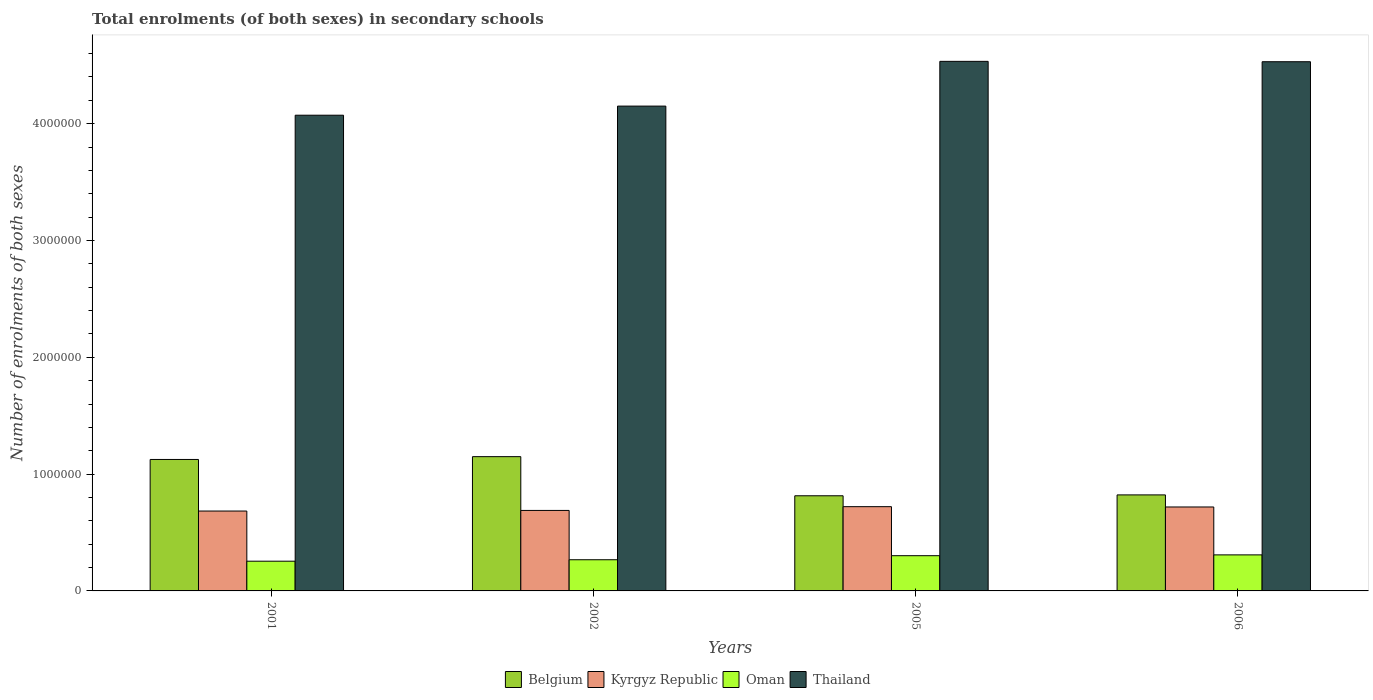How many groups of bars are there?
Ensure brevity in your answer.  4. Are the number of bars per tick equal to the number of legend labels?
Offer a very short reply. Yes. How many bars are there on the 3rd tick from the left?
Offer a terse response. 4. What is the label of the 1st group of bars from the left?
Ensure brevity in your answer.  2001. In how many cases, is the number of bars for a given year not equal to the number of legend labels?
Your answer should be very brief. 0. What is the number of enrolments in secondary schools in Belgium in 2005?
Your answer should be compact. 8.15e+05. Across all years, what is the maximum number of enrolments in secondary schools in Thailand?
Your response must be concise. 4.53e+06. Across all years, what is the minimum number of enrolments in secondary schools in Kyrgyz Republic?
Keep it short and to the point. 6.84e+05. What is the total number of enrolments in secondary schools in Belgium in the graph?
Ensure brevity in your answer.  3.91e+06. What is the difference between the number of enrolments in secondary schools in Belgium in 2001 and that in 2005?
Your response must be concise. 3.11e+05. What is the difference between the number of enrolments in secondary schools in Kyrgyz Republic in 2005 and the number of enrolments in secondary schools in Oman in 2001?
Your answer should be compact. 4.67e+05. What is the average number of enrolments in secondary schools in Oman per year?
Your response must be concise. 2.83e+05. In the year 2001, what is the difference between the number of enrolments in secondary schools in Oman and number of enrolments in secondary schools in Kyrgyz Republic?
Give a very brief answer. -4.29e+05. What is the ratio of the number of enrolments in secondary schools in Kyrgyz Republic in 2005 to that in 2006?
Ensure brevity in your answer.  1. Is the difference between the number of enrolments in secondary schools in Oman in 2001 and 2006 greater than the difference between the number of enrolments in secondary schools in Kyrgyz Republic in 2001 and 2006?
Give a very brief answer. No. What is the difference between the highest and the second highest number of enrolments in secondary schools in Oman?
Offer a terse response. 6940. What is the difference between the highest and the lowest number of enrolments in secondary schools in Oman?
Offer a terse response. 5.40e+04. In how many years, is the number of enrolments in secondary schools in Belgium greater than the average number of enrolments in secondary schools in Belgium taken over all years?
Make the answer very short. 2. Is the sum of the number of enrolments in secondary schools in Kyrgyz Republic in 2005 and 2006 greater than the maximum number of enrolments in secondary schools in Belgium across all years?
Provide a succinct answer. Yes. What does the 4th bar from the left in 2006 represents?
Provide a short and direct response. Thailand. What does the 1st bar from the right in 2001 represents?
Give a very brief answer. Thailand. How many bars are there?
Provide a short and direct response. 16. What is the difference between two consecutive major ticks on the Y-axis?
Offer a very short reply. 1.00e+06. Are the values on the major ticks of Y-axis written in scientific E-notation?
Provide a short and direct response. No. Does the graph contain any zero values?
Your answer should be very brief. No. Does the graph contain grids?
Keep it short and to the point. No. Where does the legend appear in the graph?
Offer a terse response. Bottom center. How are the legend labels stacked?
Your answer should be compact. Horizontal. What is the title of the graph?
Make the answer very short. Total enrolments (of both sexes) in secondary schools. Does "Isle of Man" appear as one of the legend labels in the graph?
Provide a succinct answer. No. What is the label or title of the X-axis?
Offer a very short reply. Years. What is the label or title of the Y-axis?
Offer a very short reply. Number of enrolments of both sexes. What is the Number of enrolments of both sexes of Belgium in 2001?
Provide a short and direct response. 1.13e+06. What is the Number of enrolments of both sexes of Kyrgyz Republic in 2001?
Provide a succinct answer. 6.84e+05. What is the Number of enrolments of both sexes in Oman in 2001?
Keep it short and to the point. 2.54e+05. What is the Number of enrolments of both sexes in Thailand in 2001?
Your response must be concise. 4.07e+06. What is the Number of enrolments of both sexes of Belgium in 2002?
Ensure brevity in your answer.  1.15e+06. What is the Number of enrolments of both sexes of Kyrgyz Republic in 2002?
Ensure brevity in your answer.  6.89e+05. What is the Number of enrolments of both sexes of Oman in 2002?
Your answer should be very brief. 2.67e+05. What is the Number of enrolments of both sexes of Thailand in 2002?
Your response must be concise. 4.15e+06. What is the Number of enrolments of both sexes in Belgium in 2005?
Provide a short and direct response. 8.15e+05. What is the Number of enrolments of both sexes of Kyrgyz Republic in 2005?
Your answer should be compact. 7.21e+05. What is the Number of enrolments of both sexes of Oman in 2005?
Ensure brevity in your answer.  3.02e+05. What is the Number of enrolments of both sexes in Thailand in 2005?
Ensure brevity in your answer.  4.53e+06. What is the Number of enrolments of both sexes in Belgium in 2006?
Your answer should be very brief. 8.22e+05. What is the Number of enrolments of both sexes in Kyrgyz Republic in 2006?
Provide a succinct answer. 7.19e+05. What is the Number of enrolments of both sexes in Oman in 2006?
Make the answer very short. 3.09e+05. What is the Number of enrolments of both sexes in Thailand in 2006?
Your answer should be compact. 4.53e+06. Across all years, what is the maximum Number of enrolments of both sexes in Belgium?
Keep it short and to the point. 1.15e+06. Across all years, what is the maximum Number of enrolments of both sexes of Kyrgyz Republic?
Offer a very short reply. 7.21e+05. Across all years, what is the maximum Number of enrolments of both sexes in Oman?
Your response must be concise. 3.09e+05. Across all years, what is the maximum Number of enrolments of both sexes of Thailand?
Your answer should be very brief. 4.53e+06. Across all years, what is the minimum Number of enrolments of both sexes of Belgium?
Offer a very short reply. 8.15e+05. Across all years, what is the minimum Number of enrolments of both sexes in Kyrgyz Republic?
Offer a very short reply. 6.84e+05. Across all years, what is the minimum Number of enrolments of both sexes of Oman?
Make the answer very short. 2.54e+05. Across all years, what is the minimum Number of enrolments of both sexes of Thailand?
Offer a terse response. 4.07e+06. What is the total Number of enrolments of both sexes in Belgium in the graph?
Offer a terse response. 3.91e+06. What is the total Number of enrolments of both sexes of Kyrgyz Republic in the graph?
Your response must be concise. 2.81e+06. What is the total Number of enrolments of both sexes of Oman in the graph?
Keep it short and to the point. 1.13e+06. What is the total Number of enrolments of both sexes of Thailand in the graph?
Offer a very short reply. 1.73e+07. What is the difference between the Number of enrolments of both sexes of Belgium in 2001 and that in 2002?
Offer a terse response. -2.41e+04. What is the difference between the Number of enrolments of both sexes in Kyrgyz Republic in 2001 and that in 2002?
Keep it short and to the point. -5204. What is the difference between the Number of enrolments of both sexes of Oman in 2001 and that in 2002?
Make the answer very short. -1.24e+04. What is the difference between the Number of enrolments of both sexes of Thailand in 2001 and that in 2002?
Ensure brevity in your answer.  -7.81e+04. What is the difference between the Number of enrolments of both sexes of Belgium in 2001 and that in 2005?
Provide a short and direct response. 3.11e+05. What is the difference between the Number of enrolments of both sexes in Kyrgyz Republic in 2001 and that in 2005?
Provide a short and direct response. -3.74e+04. What is the difference between the Number of enrolments of both sexes in Oman in 2001 and that in 2005?
Your answer should be compact. -4.71e+04. What is the difference between the Number of enrolments of both sexes in Thailand in 2001 and that in 2005?
Provide a succinct answer. -4.61e+05. What is the difference between the Number of enrolments of both sexes in Belgium in 2001 and that in 2006?
Your answer should be compact. 3.03e+05. What is the difference between the Number of enrolments of both sexes of Kyrgyz Republic in 2001 and that in 2006?
Offer a very short reply. -3.48e+04. What is the difference between the Number of enrolments of both sexes in Oman in 2001 and that in 2006?
Your answer should be compact. -5.40e+04. What is the difference between the Number of enrolments of both sexes in Thailand in 2001 and that in 2006?
Your answer should be very brief. -4.58e+05. What is the difference between the Number of enrolments of both sexes of Belgium in 2002 and that in 2005?
Ensure brevity in your answer.  3.35e+05. What is the difference between the Number of enrolments of both sexes of Kyrgyz Republic in 2002 and that in 2005?
Your answer should be very brief. -3.22e+04. What is the difference between the Number of enrolments of both sexes in Oman in 2002 and that in 2005?
Make the answer very short. -3.46e+04. What is the difference between the Number of enrolments of both sexes in Thailand in 2002 and that in 2005?
Provide a short and direct response. -3.83e+05. What is the difference between the Number of enrolments of both sexes in Belgium in 2002 and that in 2006?
Your answer should be very brief. 3.27e+05. What is the difference between the Number of enrolments of both sexes of Kyrgyz Republic in 2002 and that in 2006?
Ensure brevity in your answer.  -2.95e+04. What is the difference between the Number of enrolments of both sexes of Oman in 2002 and that in 2006?
Your response must be concise. -4.16e+04. What is the difference between the Number of enrolments of both sexes in Thailand in 2002 and that in 2006?
Your answer should be compact. -3.80e+05. What is the difference between the Number of enrolments of both sexes of Belgium in 2005 and that in 2006?
Ensure brevity in your answer.  -7457. What is the difference between the Number of enrolments of both sexes in Kyrgyz Republic in 2005 and that in 2006?
Make the answer very short. 2620. What is the difference between the Number of enrolments of both sexes in Oman in 2005 and that in 2006?
Make the answer very short. -6940. What is the difference between the Number of enrolments of both sexes of Thailand in 2005 and that in 2006?
Offer a very short reply. 3144. What is the difference between the Number of enrolments of both sexes of Belgium in 2001 and the Number of enrolments of both sexes of Kyrgyz Republic in 2002?
Your answer should be compact. 4.36e+05. What is the difference between the Number of enrolments of both sexes of Belgium in 2001 and the Number of enrolments of both sexes of Oman in 2002?
Make the answer very short. 8.58e+05. What is the difference between the Number of enrolments of both sexes in Belgium in 2001 and the Number of enrolments of both sexes in Thailand in 2002?
Your answer should be compact. -3.02e+06. What is the difference between the Number of enrolments of both sexes of Kyrgyz Republic in 2001 and the Number of enrolments of both sexes of Oman in 2002?
Your response must be concise. 4.17e+05. What is the difference between the Number of enrolments of both sexes of Kyrgyz Republic in 2001 and the Number of enrolments of both sexes of Thailand in 2002?
Provide a short and direct response. -3.47e+06. What is the difference between the Number of enrolments of both sexes of Oman in 2001 and the Number of enrolments of both sexes of Thailand in 2002?
Offer a very short reply. -3.90e+06. What is the difference between the Number of enrolments of both sexes in Belgium in 2001 and the Number of enrolments of both sexes in Kyrgyz Republic in 2005?
Offer a very short reply. 4.04e+05. What is the difference between the Number of enrolments of both sexes in Belgium in 2001 and the Number of enrolments of both sexes in Oman in 2005?
Offer a very short reply. 8.24e+05. What is the difference between the Number of enrolments of both sexes of Belgium in 2001 and the Number of enrolments of both sexes of Thailand in 2005?
Ensure brevity in your answer.  -3.41e+06. What is the difference between the Number of enrolments of both sexes of Kyrgyz Republic in 2001 and the Number of enrolments of both sexes of Oman in 2005?
Provide a succinct answer. 3.82e+05. What is the difference between the Number of enrolments of both sexes in Kyrgyz Republic in 2001 and the Number of enrolments of both sexes in Thailand in 2005?
Keep it short and to the point. -3.85e+06. What is the difference between the Number of enrolments of both sexes in Oman in 2001 and the Number of enrolments of both sexes in Thailand in 2005?
Make the answer very short. -4.28e+06. What is the difference between the Number of enrolments of both sexes in Belgium in 2001 and the Number of enrolments of both sexes in Kyrgyz Republic in 2006?
Your answer should be compact. 4.07e+05. What is the difference between the Number of enrolments of both sexes of Belgium in 2001 and the Number of enrolments of both sexes of Oman in 2006?
Offer a terse response. 8.17e+05. What is the difference between the Number of enrolments of both sexes of Belgium in 2001 and the Number of enrolments of both sexes of Thailand in 2006?
Ensure brevity in your answer.  -3.40e+06. What is the difference between the Number of enrolments of both sexes of Kyrgyz Republic in 2001 and the Number of enrolments of both sexes of Oman in 2006?
Offer a terse response. 3.75e+05. What is the difference between the Number of enrolments of both sexes of Kyrgyz Republic in 2001 and the Number of enrolments of both sexes of Thailand in 2006?
Offer a terse response. -3.85e+06. What is the difference between the Number of enrolments of both sexes in Oman in 2001 and the Number of enrolments of both sexes in Thailand in 2006?
Your response must be concise. -4.28e+06. What is the difference between the Number of enrolments of both sexes of Belgium in 2002 and the Number of enrolments of both sexes of Kyrgyz Republic in 2005?
Provide a short and direct response. 4.28e+05. What is the difference between the Number of enrolments of both sexes of Belgium in 2002 and the Number of enrolments of both sexes of Oman in 2005?
Offer a very short reply. 8.48e+05. What is the difference between the Number of enrolments of both sexes in Belgium in 2002 and the Number of enrolments of both sexes in Thailand in 2005?
Offer a very short reply. -3.38e+06. What is the difference between the Number of enrolments of both sexes in Kyrgyz Republic in 2002 and the Number of enrolments of both sexes in Oman in 2005?
Keep it short and to the point. 3.87e+05. What is the difference between the Number of enrolments of both sexes in Kyrgyz Republic in 2002 and the Number of enrolments of both sexes in Thailand in 2005?
Offer a terse response. -3.84e+06. What is the difference between the Number of enrolments of both sexes in Oman in 2002 and the Number of enrolments of both sexes in Thailand in 2005?
Your answer should be compact. -4.27e+06. What is the difference between the Number of enrolments of both sexes of Belgium in 2002 and the Number of enrolments of both sexes of Kyrgyz Republic in 2006?
Give a very brief answer. 4.31e+05. What is the difference between the Number of enrolments of both sexes of Belgium in 2002 and the Number of enrolments of both sexes of Oman in 2006?
Provide a short and direct response. 8.41e+05. What is the difference between the Number of enrolments of both sexes in Belgium in 2002 and the Number of enrolments of both sexes in Thailand in 2006?
Offer a terse response. -3.38e+06. What is the difference between the Number of enrolments of both sexes of Kyrgyz Republic in 2002 and the Number of enrolments of both sexes of Oman in 2006?
Keep it short and to the point. 3.81e+05. What is the difference between the Number of enrolments of both sexes in Kyrgyz Republic in 2002 and the Number of enrolments of both sexes in Thailand in 2006?
Give a very brief answer. -3.84e+06. What is the difference between the Number of enrolments of both sexes in Oman in 2002 and the Number of enrolments of both sexes in Thailand in 2006?
Your answer should be compact. -4.26e+06. What is the difference between the Number of enrolments of both sexes of Belgium in 2005 and the Number of enrolments of both sexes of Kyrgyz Republic in 2006?
Offer a very short reply. 9.60e+04. What is the difference between the Number of enrolments of both sexes of Belgium in 2005 and the Number of enrolments of both sexes of Oman in 2006?
Your response must be concise. 5.06e+05. What is the difference between the Number of enrolments of both sexes of Belgium in 2005 and the Number of enrolments of both sexes of Thailand in 2006?
Provide a short and direct response. -3.72e+06. What is the difference between the Number of enrolments of both sexes of Kyrgyz Republic in 2005 and the Number of enrolments of both sexes of Oman in 2006?
Your answer should be very brief. 4.13e+05. What is the difference between the Number of enrolments of both sexes in Kyrgyz Republic in 2005 and the Number of enrolments of both sexes in Thailand in 2006?
Your response must be concise. -3.81e+06. What is the difference between the Number of enrolments of both sexes in Oman in 2005 and the Number of enrolments of both sexes in Thailand in 2006?
Make the answer very short. -4.23e+06. What is the average Number of enrolments of both sexes of Belgium per year?
Make the answer very short. 9.78e+05. What is the average Number of enrolments of both sexes in Kyrgyz Republic per year?
Provide a succinct answer. 7.03e+05. What is the average Number of enrolments of both sexes of Oman per year?
Offer a very short reply. 2.83e+05. What is the average Number of enrolments of both sexes in Thailand per year?
Keep it short and to the point. 4.32e+06. In the year 2001, what is the difference between the Number of enrolments of both sexes of Belgium and Number of enrolments of both sexes of Kyrgyz Republic?
Provide a succinct answer. 4.41e+05. In the year 2001, what is the difference between the Number of enrolments of both sexes of Belgium and Number of enrolments of both sexes of Oman?
Provide a short and direct response. 8.71e+05. In the year 2001, what is the difference between the Number of enrolments of both sexes in Belgium and Number of enrolments of both sexes in Thailand?
Your answer should be very brief. -2.95e+06. In the year 2001, what is the difference between the Number of enrolments of both sexes of Kyrgyz Republic and Number of enrolments of both sexes of Oman?
Your answer should be very brief. 4.29e+05. In the year 2001, what is the difference between the Number of enrolments of both sexes of Kyrgyz Republic and Number of enrolments of both sexes of Thailand?
Offer a very short reply. -3.39e+06. In the year 2001, what is the difference between the Number of enrolments of both sexes of Oman and Number of enrolments of both sexes of Thailand?
Provide a short and direct response. -3.82e+06. In the year 2002, what is the difference between the Number of enrolments of both sexes in Belgium and Number of enrolments of both sexes in Kyrgyz Republic?
Make the answer very short. 4.60e+05. In the year 2002, what is the difference between the Number of enrolments of both sexes in Belgium and Number of enrolments of both sexes in Oman?
Provide a succinct answer. 8.82e+05. In the year 2002, what is the difference between the Number of enrolments of both sexes in Belgium and Number of enrolments of both sexes in Thailand?
Give a very brief answer. -3.00e+06. In the year 2002, what is the difference between the Number of enrolments of both sexes of Kyrgyz Republic and Number of enrolments of both sexes of Oman?
Your answer should be very brief. 4.22e+05. In the year 2002, what is the difference between the Number of enrolments of both sexes in Kyrgyz Republic and Number of enrolments of both sexes in Thailand?
Give a very brief answer. -3.46e+06. In the year 2002, what is the difference between the Number of enrolments of both sexes in Oman and Number of enrolments of both sexes in Thailand?
Provide a succinct answer. -3.88e+06. In the year 2005, what is the difference between the Number of enrolments of both sexes of Belgium and Number of enrolments of both sexes of Kyrgyz Republic?
Give a very brief answer. 9.33e+04. In the year 2005, what is the difference between the Number of enrolments of both sexes of Belgium and Number of enrolments of both sexes of Oman?
Make the answer very short. 5.13e+05. In the year 2005, what is the difference between the Number of enrolments of both sexes of Belgium and Number of enrolments of both sexes of Thailand?
Your answer should be compact. -3.72e+06. In the year 2005, what is the difference between the Number of enrolments of both sexes in Kyrgyz Republic and Number of enrolments of both sexes in Oman?
Ensure brevity in your answer.  4.20e+05. In the year 2005, what is the difference between the Number of enrolments of both sexes of Kyrgyz Republic and Number of enrolments of both sexes of Thailand?
Offer a very short reply. -3.81e+06. In the year 2005, what is the difference between the Number of enrolments of both sexes in Oman and Number of enrolments of both sexes in Thailand?
Make the answer very short. -4.23e+06. In the year 2006, what is the difference between the Number of enrolments of both sexes of Belgium and Number of enrolments of both sexes of Kyrgyz Republic?
Provide a succinct answer. 1.03e+05. In the year 2006, what is the difference between the Number of enrolments of both sexes of Belgium and Number of enrolments of both sexes of Oman?
Offer a terse response. 5.13e+05. In the year 2006, what is the difference between the Number of enrolments of both sexes of Belgium and Number of enrolments of both sexes of Thailand?
Offer a very short reply. -3.71e+06. In the year 2006, what is the difference between the Number of enrolments of both sexes in Kyrgyz Republic and Number of enrolments of both sexes in Oman?
Give a very brief answer. 4.10e+05. In the year 2006, what is the difference between the Number of enrolments of both sexes in Kyrgyz Republic and Number of enrolments of both sexes in Thailand?
Keep it short and to the point. -3.81e+06. In the year 2006, what is the difference between the Number of enrolments of both sexes of Oman and Number of enrolments of both sexes of Thailand?
Make the answer very short. -4.22e+06. What is the ratio of the Number of enrolments of both sexes of Belgium in 2001 to that in 2002?
Offer a very short reply. 0.98. What is the ratio of the Number of enrolments of both sexes in Kyrgyz Republic in 2001 to that in 2002?
Ensure brevity in your answer.  0.99. What is the ratio of the Number of enrolments of both sexes in Oman in 2001 to that in 2002?
Provide a succinct answer. 0.95. What is the ratio of the Number of enrolments of both sexes of Thailand in 2001 to that in 2002?
Provide a succinct answer. 0.98. What is the ratio of the Number of enrolments of both sexes in Belgium in 2001 to that in 2005?
Provide a short and direct response. 1.38. What is the ratio of the Number of enrolments of both sexes of Kyrgyz Republic in 2001 to that in 2005?
Provide a short and direct response. 0.95. What is the ratio of the Number of enrolments of both sexes in Oman in 2001 to that in 2005?
Give a very brief answer. 0.84. What is the ratio of the Number of enrolments of both sexes in Thailand in 2001 to that in 2005?
Ensure brevity in your answer.  0.9. What is the ratio of the Number of enrolments of both sexes of Belgium in 2001 to that in 2006?
Your answer should be very brief. 1.37. What is the ratio of the Number of enrolments of both sexes of Kyrgyz Republic in 2001 to that in 2006?
Ensure brevity in your answer.  0.95. What is the ratio of the Number of enrolments of both sexes of Oman in 2001 to that in 2006?
Your response must be concise. 0.82. What is the ratio of the Number of enrolments of both sexes of Thailand in 2001 to that in 2006?
Ensure brevity in your answer.  0.9. What is the ratio of the Number of enrolments of both sexes of Belgium in 2002 to that in 2005?
Your answer should be compact. 1.41. What is the ratio of the Number of enrolments of both sexes of Kyrgyz Republic in 2002 to that in 2005?
Your answer should be very brief. 0.96. What is the ratio of the Number of enrolments of both sexes of Oman in 2002 to that in 2005?
Keep it short and to the point. 0.89. What is the ratio of the Number of enrolments of both sexes of Thailand in 2002 to that in 2005?
Your answer should be compact. 0.92. What is the ratio of the Number of enrolments of both sexes in Belgium in 2002 to that in 2006?
Provide a succinct answer. 1.4. What is the ratio of the Number of enrolments of both sexes in Kyrgyz Republic in 2002 to that in 2006?
Your answer should be very brief. 0.96. What is the ratio of the Number of enrolments of both sexes of Oman in 2002 to that in 2006?
Your answer should be very brief. 0.87. What is the ratio of the Number of enrolments of both sexes of Thailand in 2002 to that in 2006?
Ensure brevity in your answer.  0.92. What is the ratio of the Number of enrolments of both sexes of Belgium in 2005 to that in 2006?
Your answer should be very brief. 0.99. What is the ratio of the Number of enrolments of both sexes in Oman in 2005 to that in 2006?
Make the answer very short. 0.98. What is the difference between the highest and the second highest Number of enrolments of both sexes in Belgium?
Make the answer very short. 2.41e+04. What is the difference between the highest and the second highest Number of enrolments of both sexes of Kyrgyz Republic?
Make the answer very short. 2620. What is the difference between the highest and the second highest Number of enrolments of both sexes in Oman?
Your answer should be very brief. 6940. What is the difference between the highest and the second highest Number of enrolments of both sexes in Thailand?
Provide a succinct answer. 3144. What is the difference between the highest and the lowest Number of enrolments of both sexes of Belgium?
Provide a short and direct response. 3.35e+05. What is the difference between the highest and the lowest Number of enrolments of both sexes in Kyrgyz Republic?
Give a very brief answer. 3.74e+04. What is the difference between the highest and the lowest Number of enrolments of both sexes in Oman?
Your answer should be compact. 5.40e+04. What is the difference between the highest and the lowest Number of enrolments of both sexes in Thailand?
Keep it short and to the point. 4.61e+05. 